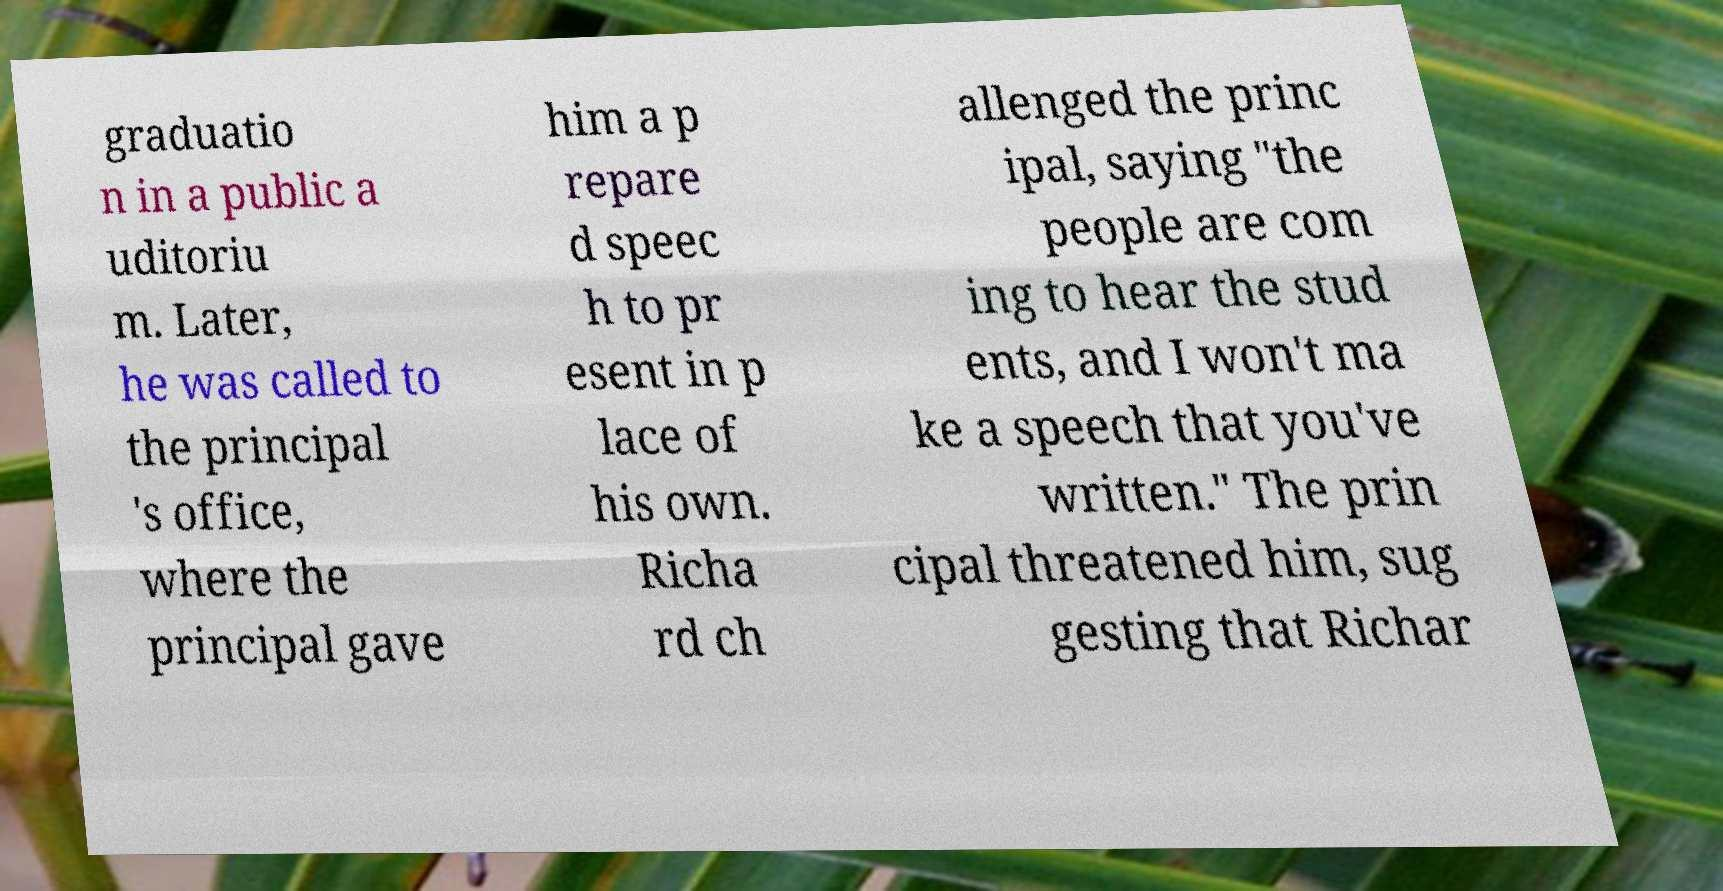Can you accurately transcribe the text from the provided image for me? graduatio n in a public a uditoriu m. Later, he was called to the principal 's office, where the principal gave him a p repare d speec h to pr esent in p lace of his own. Richa rd ch allenged the princ ipal, saying "the people are com ing to hear the stud ents, and I won't ma ke a speech that you've written." The prin cipal threatened him, sug gesting that Richar 